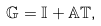Convert formula to latex. <formula><loc_0><loc_0><loc_500><loc_500>\mathbb { G } = \mathbb { I } + \mathbb { A } \mathbb { T } ,</formula> 